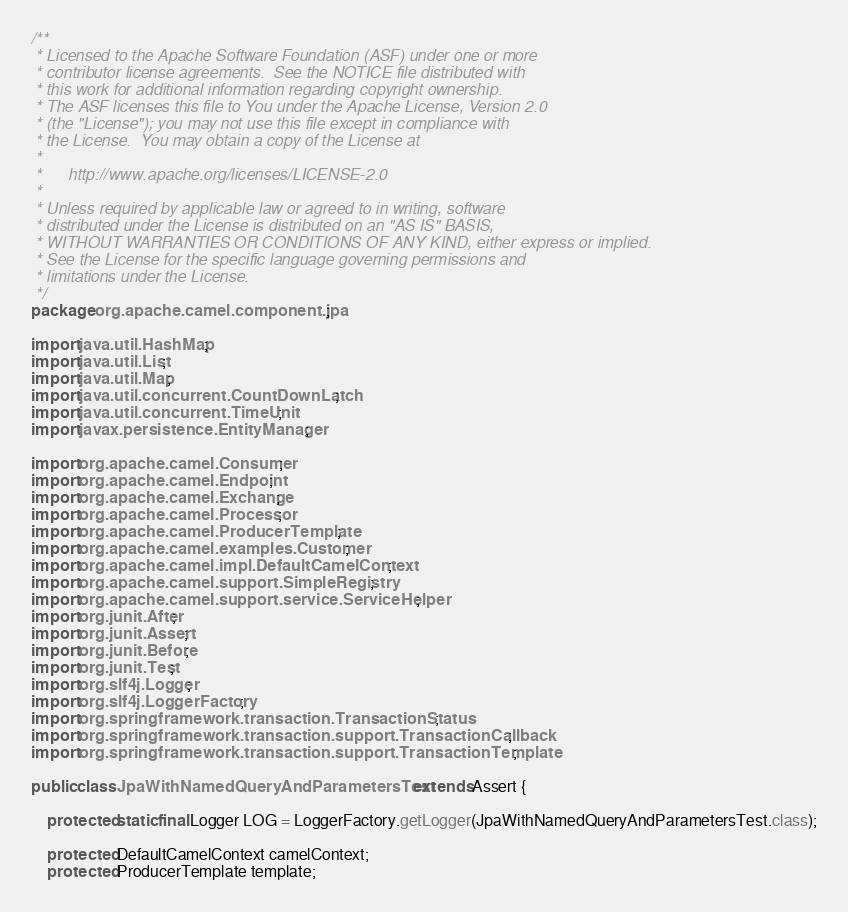<code> <loc_0><loc_0><loc_500><loc_500><_Java_>/**
 * Licensed to the Apache Software Foundation (ASF) under one or more
 * contributor license agreements.  See the NOTICE file distributed with
 * this work for additional information regarding copyright ownership.
 * The ASF licenses this file to You under the Apache License, Version 2.0
 * (the "License"); you may not use this file except in compliance with
 * the License.  You may obtain a copy of the License at
 *
 *      http://www.apache.org/licenses/LICENSE-2.0
 *
 * Unless required by applicable law or agreed to in writing, software
 * distributed under the License is distributed on an "AS IS" BASIS,
 * WITHOUT WARRANTIES OR CONDITIONS OF ANY KIND, either express or implied.
 * See the License for the specific language governing permissions and
 * limitations under the License.
 */
package org.apache.camel.component.jpa;

import java.util.HashMap;
import java.util.List;
import java.util.Map;
import java.util.concurrent.CountDownLatch;
import java.util.concurrent.TimeUnit;
import javax.persistence.EntityManager;

import org.apache.camel.Consumer;
import org.apache.camel.Endpoint;
import org.apache.camel.Exchange;
import org.apache.camel.Processor;
import org.apache.camel.ProducerTemplate;
import org.apache.camel.examples.Customer;
import org.apache.camel.impl.DefaultCamelContext;
import org.apache.camel.support.SimpleRegistry;
import org.apache.camel.support.service.ServiceHelper;
import org.junit.After;
import org.junit.Assert;
import org.junit.Before;
import org.junit.Test;
import org.slf4j.Logger;
import org.slf4j.LoggerFactory;
import org.springframework.transaction.TransactionStatus;
import org.springframework.transaction.support.TransactionCallback;
import org.springframework.transaction.support.TransactionTemplate;

public class JpaWithNamedQueryAndParametersTest extends Assert {
    
    protected static final Logger LOG = LoggerFactory.getLogger(JpaWithNamedQueryAndParametersTest.class);
    
    protected DefaultCamelContext camelContext;
    protected ProducerTemplate template;</code> 